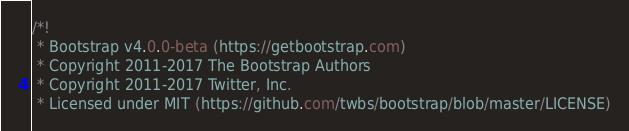<code> <loc_0><loc_0><loc_500><loc_500><_CSS_>/*!
 * Bootstrap v4.0.0-beta (https://getbootstrap.com)
 * Copyright 2011-2017 The Bootstrap Authors
 * Copyright 2011-2017 Twitter, Inc.
 * Licensed under MIT (https://github.com/twbs/bootstrap/blob/master/LICENSE)</code> 